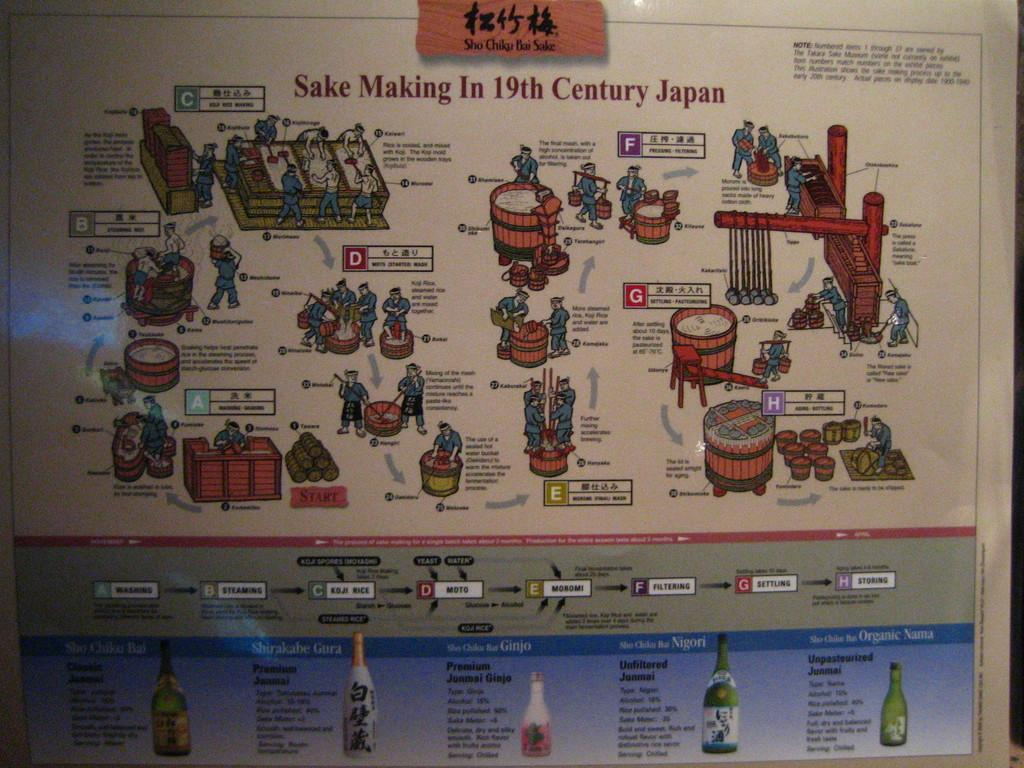<image>
Relay a brief, clear account of the picture shown. A poster whose title says Sake Making In 19th Century Japan 